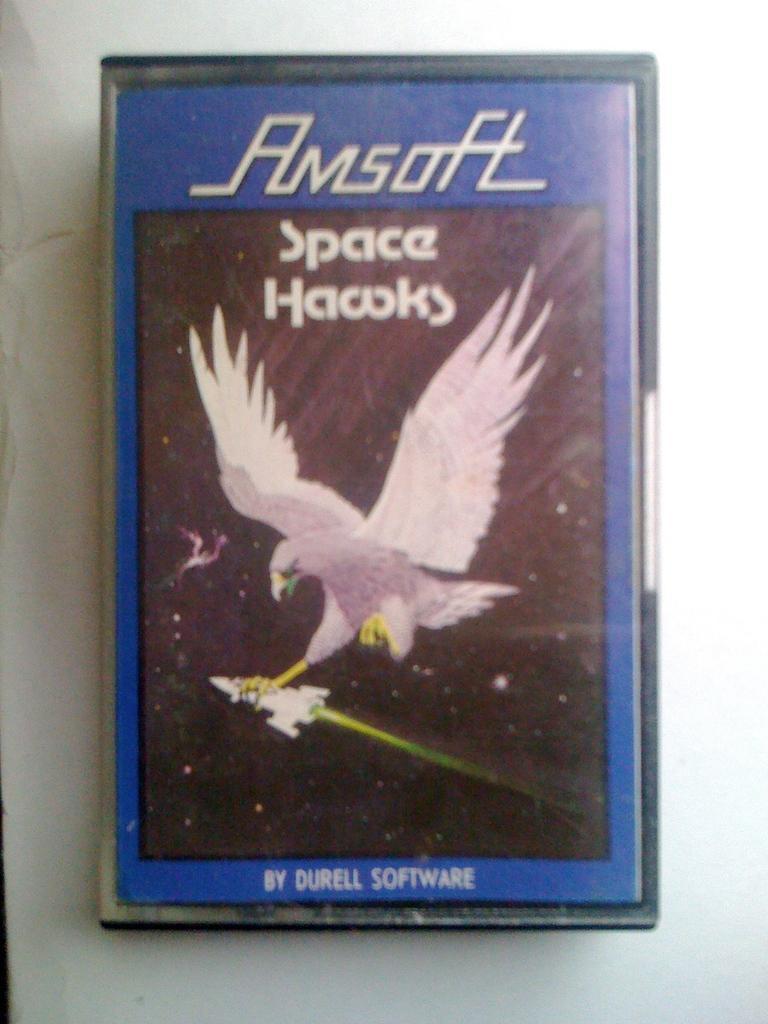Can you describe this image briefly? In the picture I can see an object. On the cover of this object I can see a white color bird and something written on it. This object is on a white color surface. 